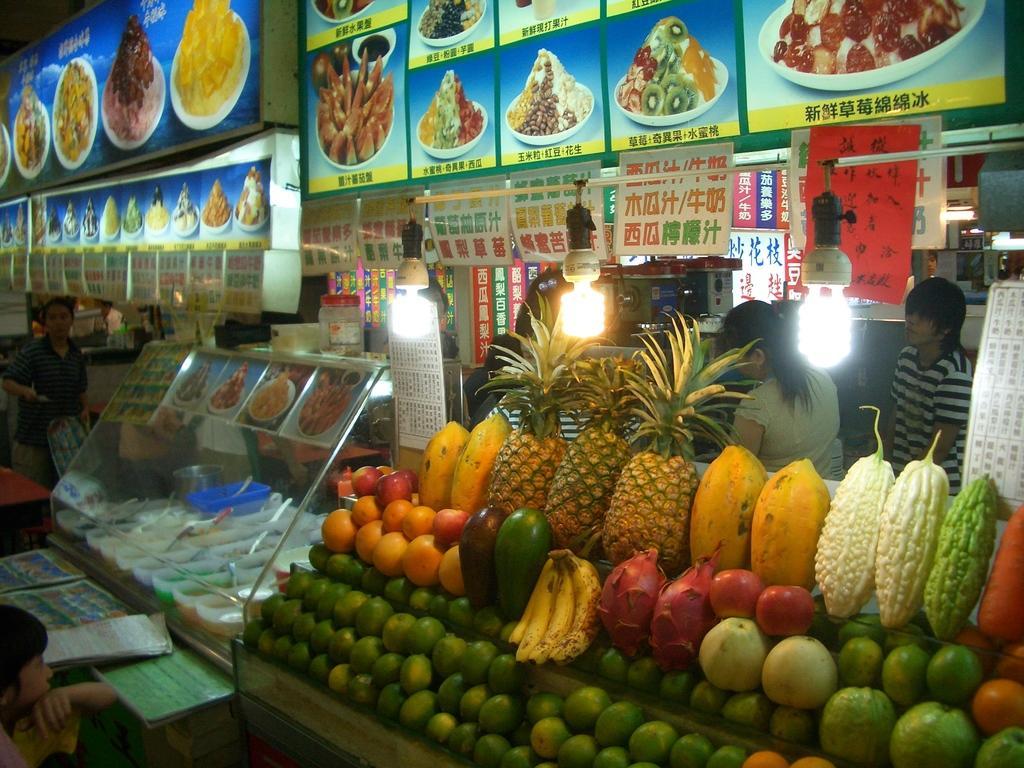Could you give a brief overview of what you see in this image? In this image, we can see fruits on the stand and in the background, we can see people and there are stores, boards, lights and we can see some bowls and spoons and some food items and there are some papers on the table and there is a person holding some objects and we can see a jar and some other objects. 